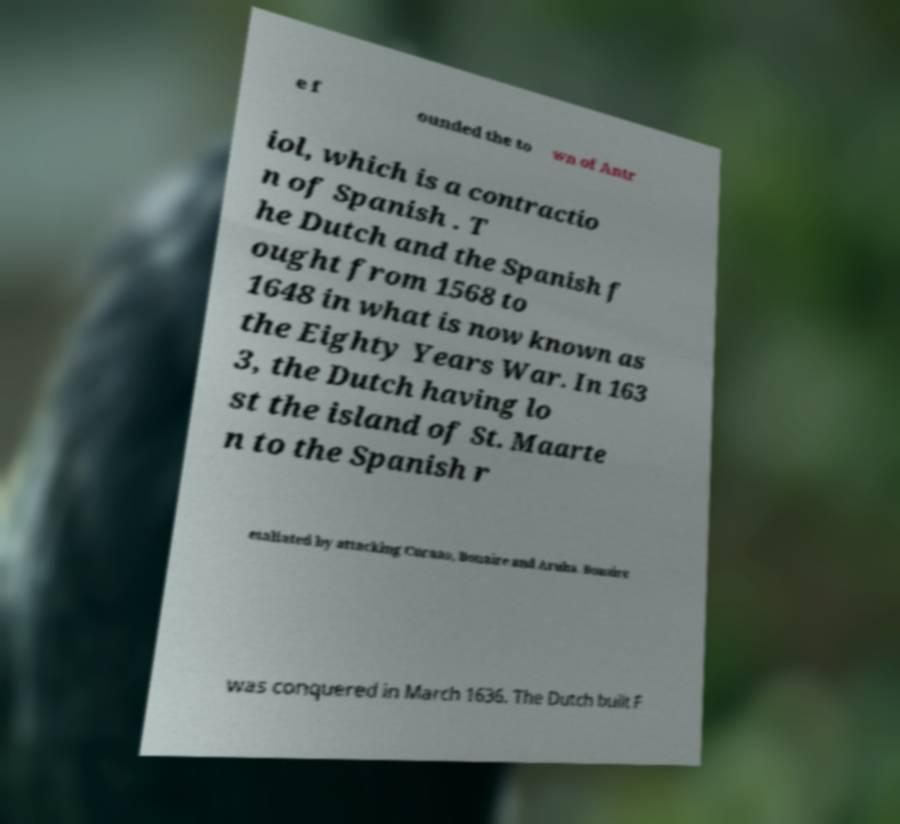What messages or text are displayed in this image? I need them in a readable, typed format. e f ounded the to wn of Antr iol, which is a contractio n of Spanish . T he Dutch and the Spanish f ought from 1568 to 1648 in what is now known as the Eighty Years War. In 163 3, the Dutch having lo st the island of St. Maarte n to the Spanish r etaliated by attacking Curaao, Bonaire and Aruba. Bonaire was conquered in March 1636. The Dutch built F 